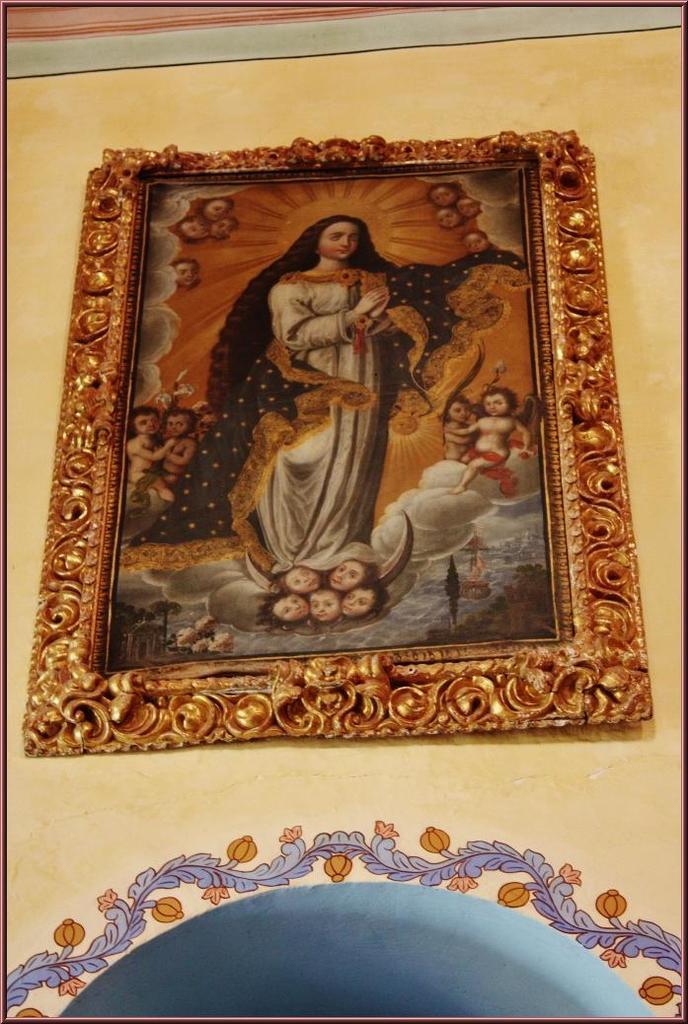Can you describe this image briefly? In this image there is a photo frame on the wall. In that a woman is standing, she wore white color dress. On the right side there is a baby. 